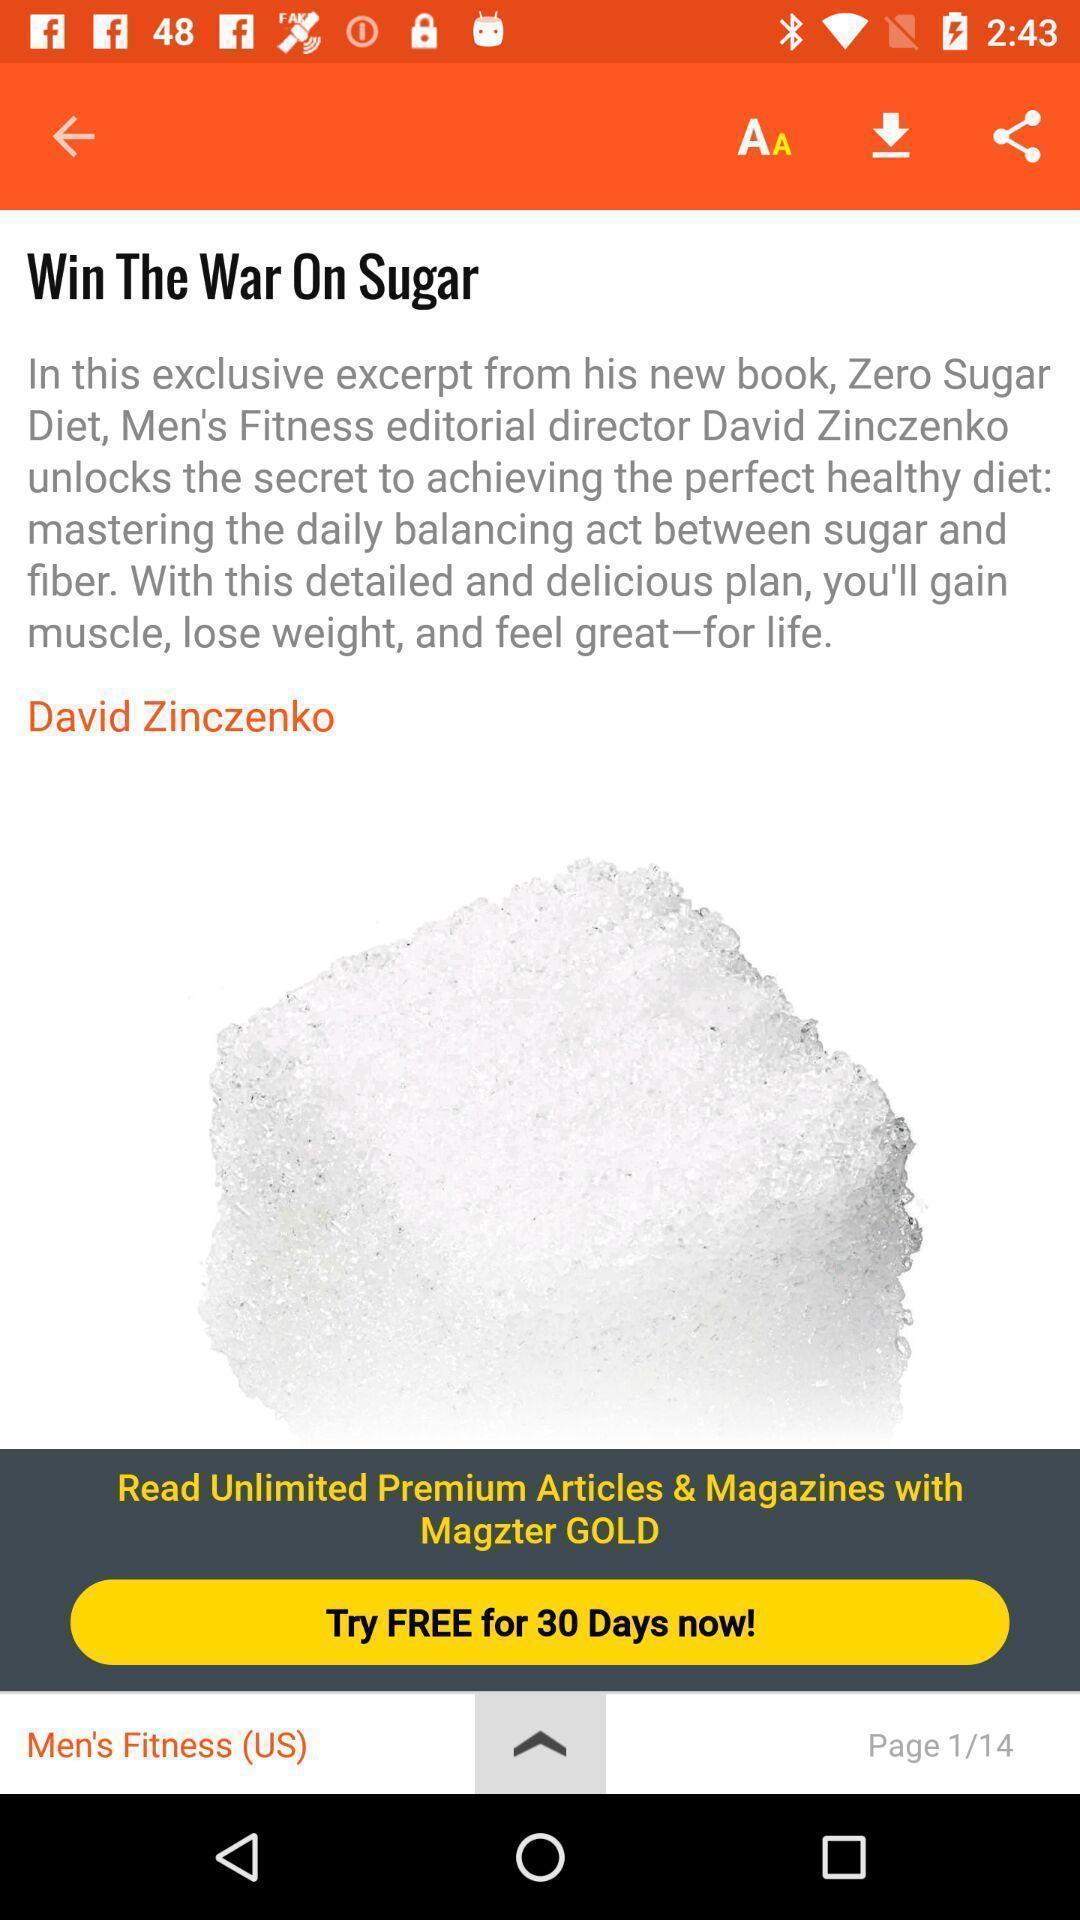Provide a textual representation of this image. Story page of a magazine app. 